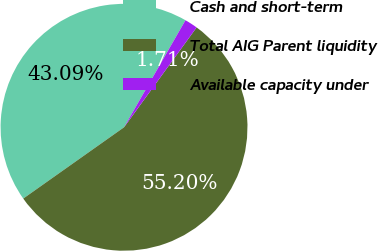<chart> <loc_0><loc_0><loc_500><loc_500><pie_chart><fcel>Cash and short-term<fcel>Total AIG Parent liquidity<fcel>Available capacity under<nl><fcel>43.09%<fcel>55.2%<fcel>1.71%<nl></chart> 